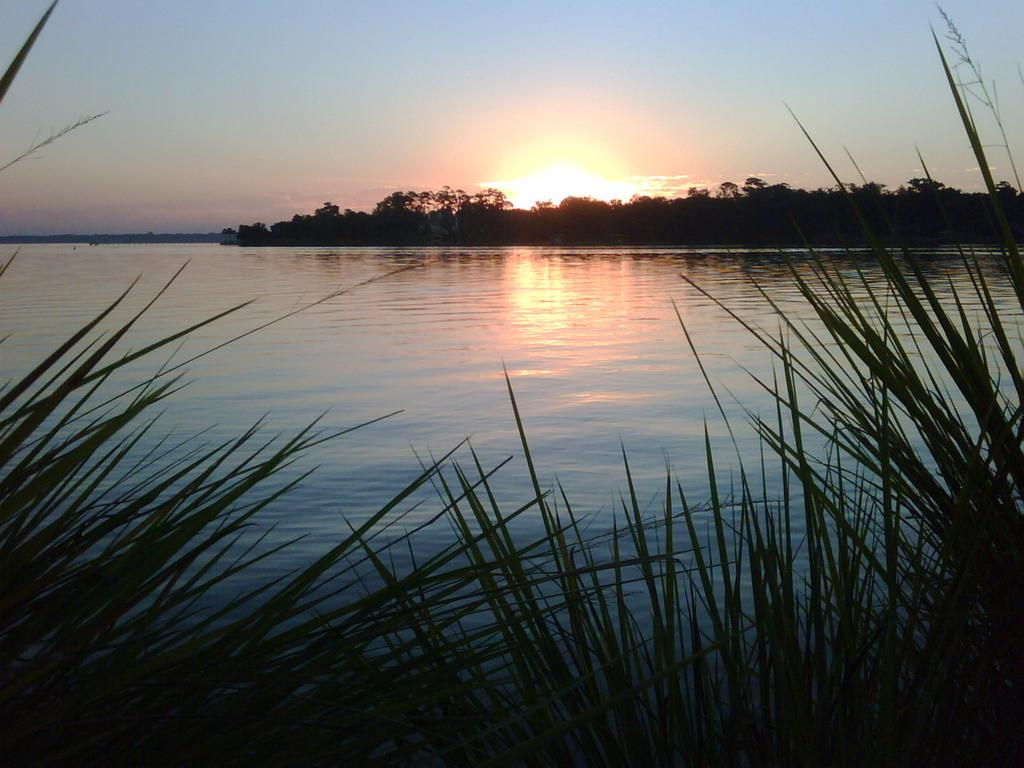What type of vegetation is in the front of the image? There are plants in the front of the image. What is located in the center of the image? There is water in the center of the image. What can be seen in the background of the image? There are trees in the background of the image. What type of tax is being discussed in the image? There is no discussion of tax in the image; it features plants, water, and trees. What suggestion is being made in the image? There is no suggestion being made in the image; it is a visual representation of plants, water, and trees. 